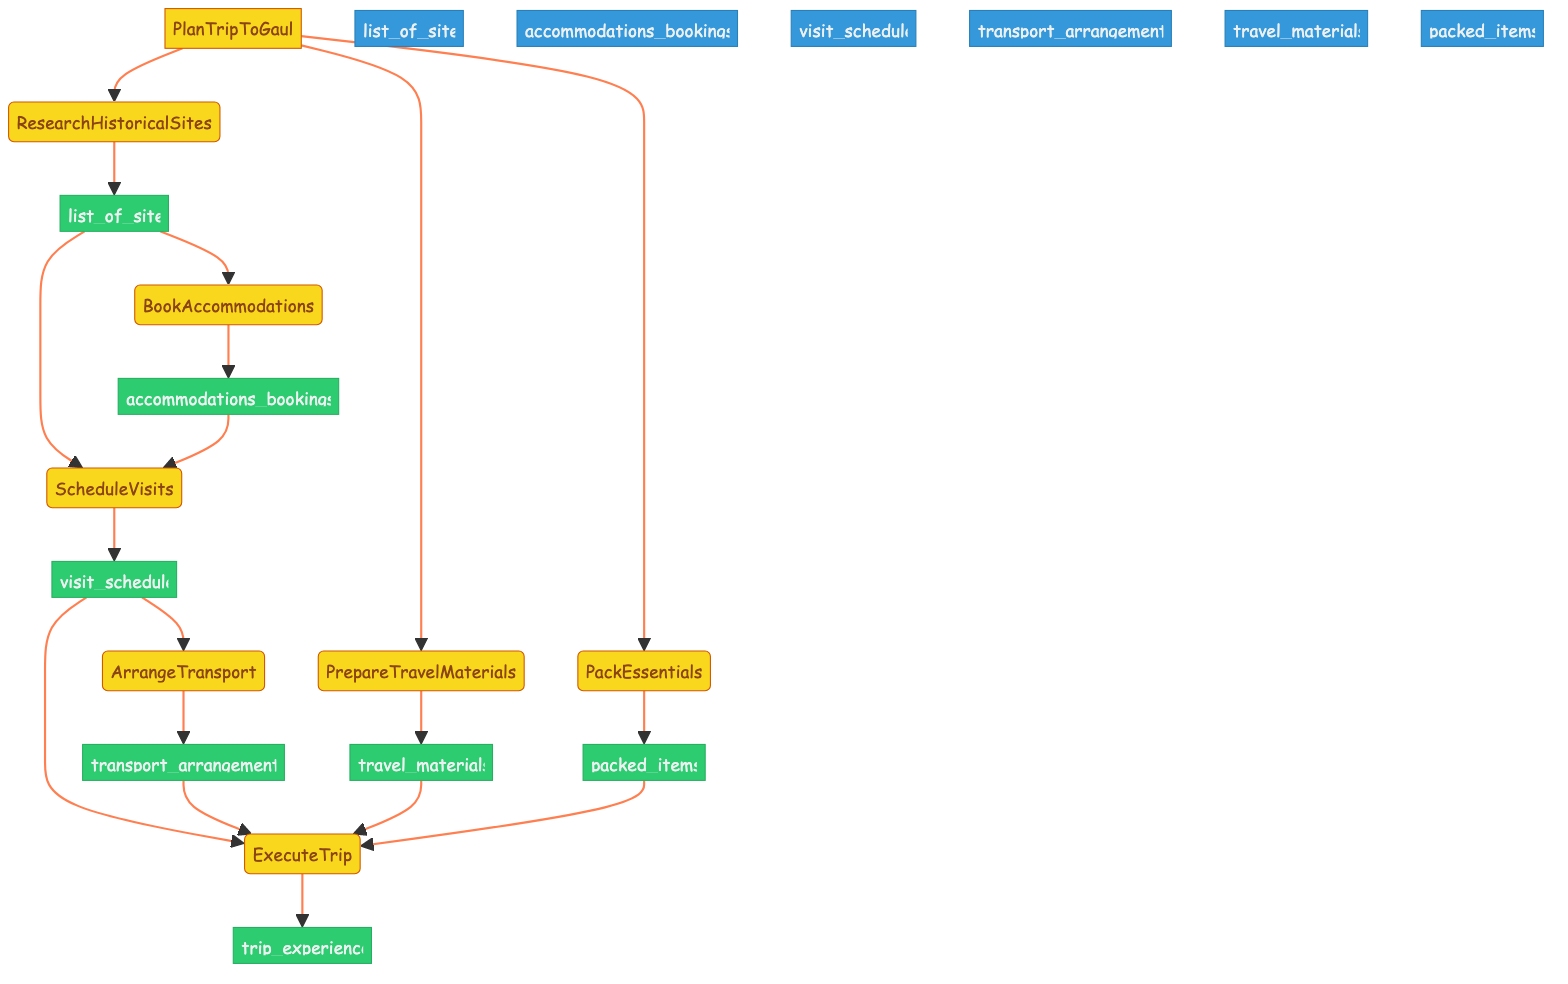What is the first step in planning the trip? The first step in the flowchart is "ResearchHistoricalSites," which involves identifying historical sites in France related to Asterix comics.
Answer: ResearchHistoricalSites How many outputs are there in total in the diagram? The diagram has a total of seven outputs indicated: list_of_sites, accommodations_bookings, visit_schedule, transport_arrangements, travel_materials, packed_items, and trip_experience.
Answer: Seven What is the output of the "BookAccommodations" step? The output from the "BookAccommodations" step is "accommodations_bookings", which refers to the bookings made for hotels or lodgings near historical sites.
Answer: accommodations_bookings Which steps require input from previous outputs? The steps that require input from previous outputs are "ScheduleVisits" (which requires list_of_sites and accommodations_bookings), "ArrangeTransport" (which requires visit_schedule), and "ExecuteTrip" (which requires visit_schedule, transport_arrangements, travel_materials, and packed_items).
Answer: ScheduleVisits, ArrangeTransport, ExecuteTrip Which step involves packing essential items? The step "PackEssentials" explicitly mentions the task of packing essential items needed for the trip, including Asterix comics.
Answer: PackEssentials What do you do after preparing travel materials? After preparing travel materials, you proceed to "PackEssentials" to pack essential items needed for the trip. This shows the sequential relationship in execution steps following the preparation of materials.
Answer: PackEssentials How many steps directly lead to the final step of "ExecuteTrip"? Four steps lead to "ExecuteTrip": "ScheduleVisits," "ArrangeTransport," "PrepareTravelMaterials," and "PackEssentials," all providing necessary inputs for the trip execution process.
Answer: Four 